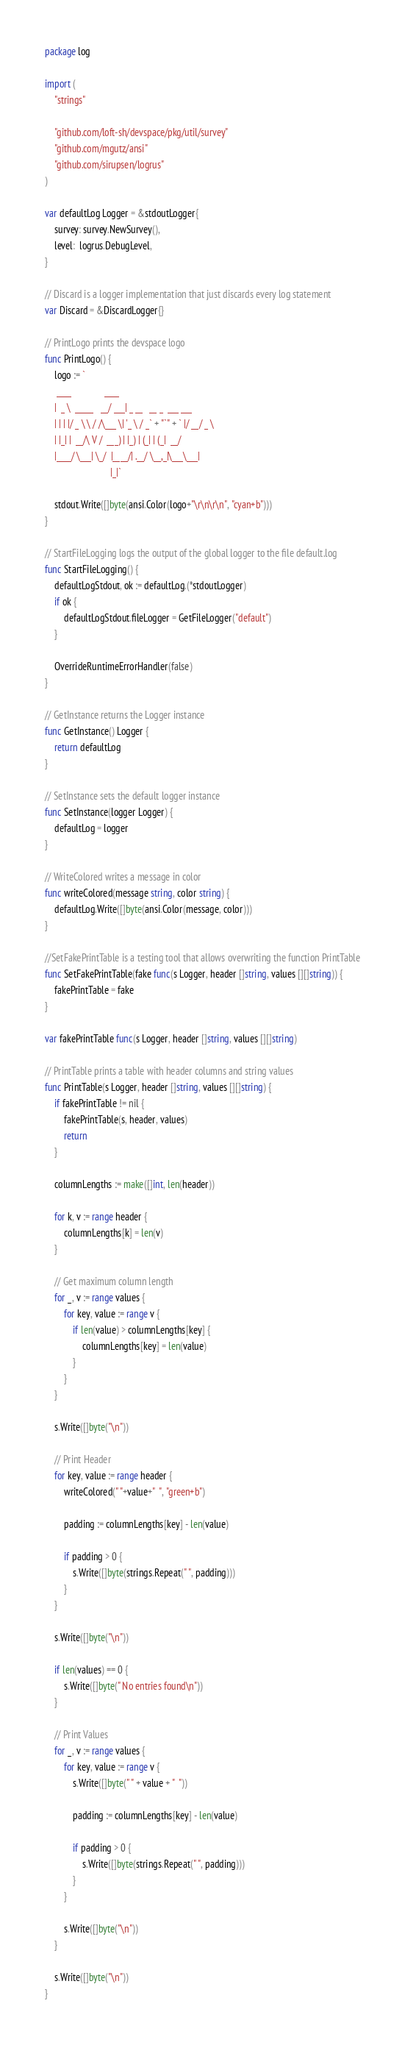Convert code to text. <code><loc_0><loc_0><loc_500><loc_500><_Go_>package log

import (
	"strings"

	"github.com/loft-sh/devspace/pkg/util/survey"
	"github.com/mgutz/ansi"
	"github.com/sirupsen/logrus"
)

var defaultLog Logger = &stdoutLogger{
	survey: survey.NewSurvey(),
	level:  logrus.DebugLevel,
}

// Discard is a logger implementation that just discards every log statement
var Discard = &DiscardLogger{}

// PrintLogo prints the devspace logo
func PrintLogo() {
	logo := `
     ____              ____                       
    |  _ \  _____   __/ ___| _ __   __ _  ___ ___ 
    | | | |/ _ \ \ / /\___ \| '_ \ / _` + "`" + ` |/ __/ _ \
    | |_| |  __/\ V /  ___) | |_) | (_| | (_|  __/
    |____/ \___| \_/  |____/| .__/ \__,_|\___\___|
                            |_|`

	stdout.Write([]byte(ansi.Color(logo+"\r\n\r\n", "cyan+b")))
}

// StartFileLogging logs the output of the global logger to the file default.log
func StartFileLogging() {
	defaultLogStdout, ok := defaultLog.(*stdoutLogger)
	if ok {
		defaultLogStdout.fileLogger = GetFileLogger("default")
	}

	OverrideRuntimeErrorHandler(false)
}

// GetInstance returns the Logger instance
func GetInstance() Logger {
	return defaultLog
}

// SetInstance sets the default logger instance
func SetInstance(logger Logger) {
	defaultLog = logger
}

// WriteColored writes a message in color
func writeColored(message string, color string) {
	defaultLog.Write([]byte(ansi.Color(message, color)))
}

//SetFakePrintTable is a testing tool that allows overwriting the function PrintTable
func SetFakePrintTable(fake func(s Logger, header []string, values [][]string)) {
	fakePrintTable = fake
}

var fakePrintTable func(s Logger, header []string, values [][]string)

// PrintTable prints a table with header columns and string values
func PrintTable(s Logger, header []string, values [][]string) {
	if fakePrintTable != nil {
		fakePrintTable(s, header, values)
		return
	}

	columnLengths := make([]int, len(header))

	for k, v := range header {
		columnLengths[k] = len(v)
	}

	// Get maximum column length
	for _, v := range values {
		for key, value := range v {
			if len(value) > columnLengths[key] {
				columnLengths[key] = len(value)
			}
		}
	}

	s.Write([]byte("\n"))

	// Print Header
	for key, value := range header {
		writeColored(" "+value+"  ", "green+b")

		padding := columnLengths[key] - len(value)

		if padding > 0 {
			s.Write([]byte(strings.Repeat(" ", padding)))
		}
	}

	s.Write([]byte("\n"))

	if len(values) == 0 {
		s.Write([]byte(" No entries found\n"))
	}

	// Print Values
	for _, v := range values {
		for key, value := range v {
			s.Write([]byte(" " + value + "  "))

			padding := columnLengths[key] - len(value)

			if padding > 0 {
				s.Write([]byte(strings.Repeat(" ", padding)))
			}
		}

		s.Write([]byte("\n"))
	}

	s.Write([]byte("\n"))
}
</code> 